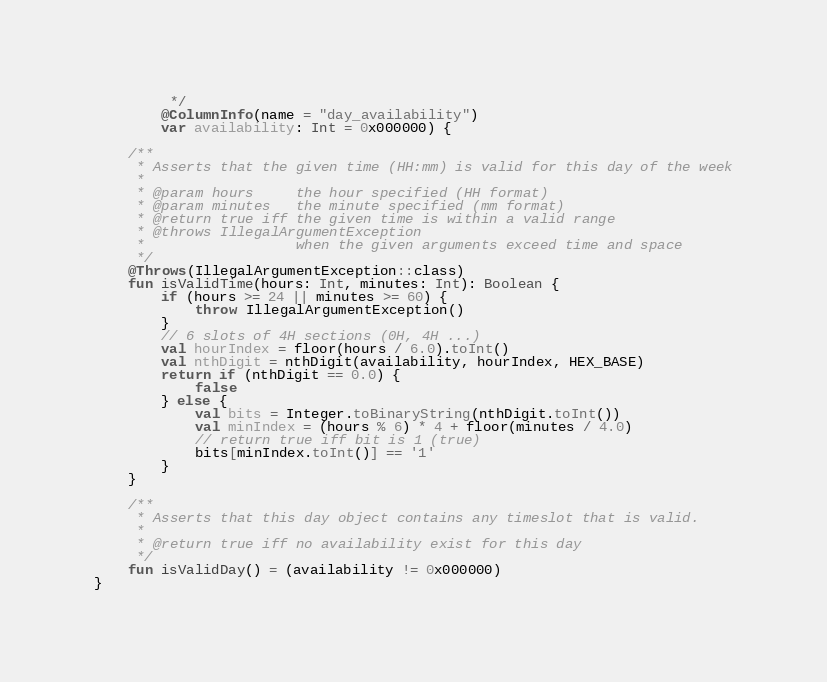Convert code to text. <code><loc_0><loc_0><loc_500><loc_500><_Kotlin_>         */
        @ColumnInfo(name = "day_availability")
        var availability: Int = 0x000000) {

    /**
     * Asserts that the given time (HH:mm) is valid for this day of the week
     *
     * @param hours     the hour specified (HH format)
     * @param minutes   the minute specified (mm format)
     * @return true iff the given time is within a valid range
     * @throws IllegalArgumentException
     *                  when the given arguments exceed time and space
     */
    @Throws(IllegalArgumentException::class)
    fun isValidTime(hours: Int, minutes: Int): Boolean {
        if (hours >= 24 || minutes >= 60) {
            throw IllegalArgumentException()
        }
        // 6 slots of 4H sections (0H, 4H ...)
        val hourIndex = floor(hours / 6.0).toInt()
        val nthDigit = nthDigit(availability, hourIndex, HEX_BASE)
        return if (nthDigit == 0.0) {
            false
        } else {
            val bits = Integer.toBinaryString(nthDigit.toInt())
            val minIndex = (hours % 6) * 4 + floor(minutes / 4.0)
            // return true iff bit is 1 (true)
            bits[minIndex.toInt()] == '1'
        }
    }

    /**
     * Asserts that this day object contains any timeslot that is valid.
     *
     * @return true iff no availability exist for this day
     */
    fun isValidDay() = (availability != 0x000000)
}</code> 